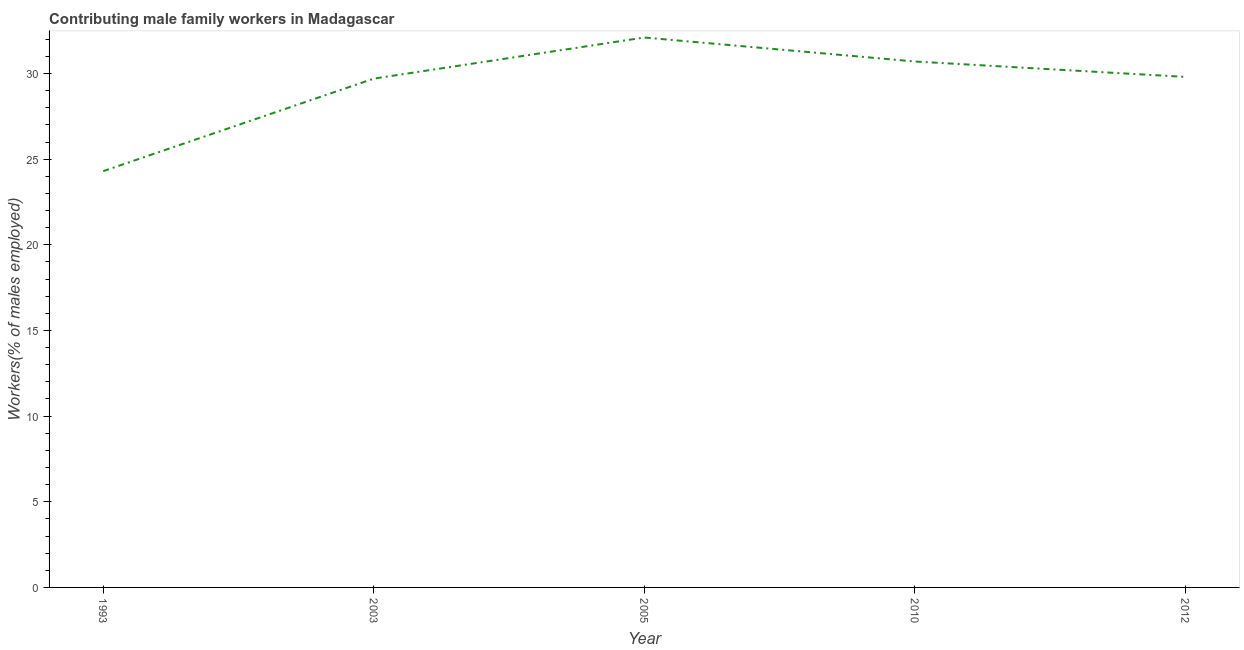What is the contributing male family workers in 2003?
Keep it short and to the point. 29.7. Across all years, what is the maximum contributing male family workers?
Make the answer very short. 32.1. Across all years, what is the minimum contributing male family workers?
Offer a terse response. 24.3. In which year was the contributing male family workers minimum?
Give a very brief answer. 1993. What is the sum of the contributing male family workers?
Give a very brief answer. 146.6. What is the difference between the contributing male family workers in 2003 and 2005?
Your answer should be compact. -2.4. What is the average contributing male family workers per year?
Your answer should be compact. 29.32. What is the median contributing male family workers?
Ensure brevity in your answer.  29.8. In how many years, is the contributing male family workers greater than 28 %?
Keep it short and to the point. 4. What is the ratio of the contributing male family workers in 1993 to that in 2005?
Your answer should be very brief. 0.76. Is the contributing male family workers in 1993 less than that in 2012?
Offer a terse response. Yes. What is the difference between the highest and the second highest contributing male family workers?
Your answer should be very brief. 1.4. Is the sum of the contributing male family workers in 2010 and 2012 greater than the maximum contributing male family workers across all years?
Make the answer very short. Yes. What is the difference between the highest and the lowest contributing male family workers?
Offer a terse response. 7.8. In how many years, is the contributing male family workers greater than the average contributing male family workers taken over all years?
Keep it short and to the point. 4. How many lines are there?
Offer a terse response. 1. What is the difference between two consecutive major ticks on the Y-axis?
Make the answer very short. 5. Are the values on the major ticks of Y-axis written in scientific E-notation?
Keep it short and to the point. No. Does the graph contain any zero values?
Give a very brief answer. No. Does the graph contain grids?
Your answer should be very brief. No. What is the title of the graph?
Your answer should be very brief. Contributing male family workers in Madagascar. What is the label or title of the Y-axis?
Offer a terse response. Workers(% of males employed). What is the Workers(% of males employed) in 1993?
Make the answer very short. 24.3. What is the Workers(% of males employed) of 2003?
Offer a terse response. 29.7. What is the Workers(% of males employed) in 2005?
Give a very brief answer. 32.1. What is the Workers(% of males employed) of 2010?
Your response must be concise. 30.7. What is the Workers(% of males employed) of 2012?
Your response must be concise. 29.8. What is the difference between the Workers(% of males employed) in 1993 and 2010?
Provide a succinct answer. -6.4. What is the difference between the Workers(% of males employed) in 1993 and 2012?
Keep it short and to the point. -5.5. What is the difference between the Workers(% of males employed) in 2003 and 2005?
Ensure brevity in your answer.  -2.4. What is the ratio of the Workers(% of males employed) in 1993 to that in 2003?
Offer a terse response. 0.82. What is the ratio of the Workers(% of males employed) in 1993 to that in 2005?
Give a very brief answer. 0.76. What is the ratio of the Workers(% of males employed) in 1993 to that in 2010?
Your answer should be very brief. 0.79. What is the ratio of the Workers(% of males employed) in 1993 to that in 2012?
Provide a short and direct response. 0.81. What is the ratio of the Workers(% of males employed) in 2003 to that in 2005?
Offer a very short reply. 0.93. What is the ratio of the Workers(% of males employed) in 2003 to that in 2010?
Your answer should be very brief. 0.97. What is the ratio of the Workers(% of males employed) in 2003 to that in 2012?
Offer a terse response. 1. What is the ratio of the Workers(% of males employed) in 2005 to that in 2010?
Your answer should be compact. 1.05. What is the ratio of the Workers(% of males employed) in 2005 to that in 2012?
Your answer should be very brief. 1.08. 